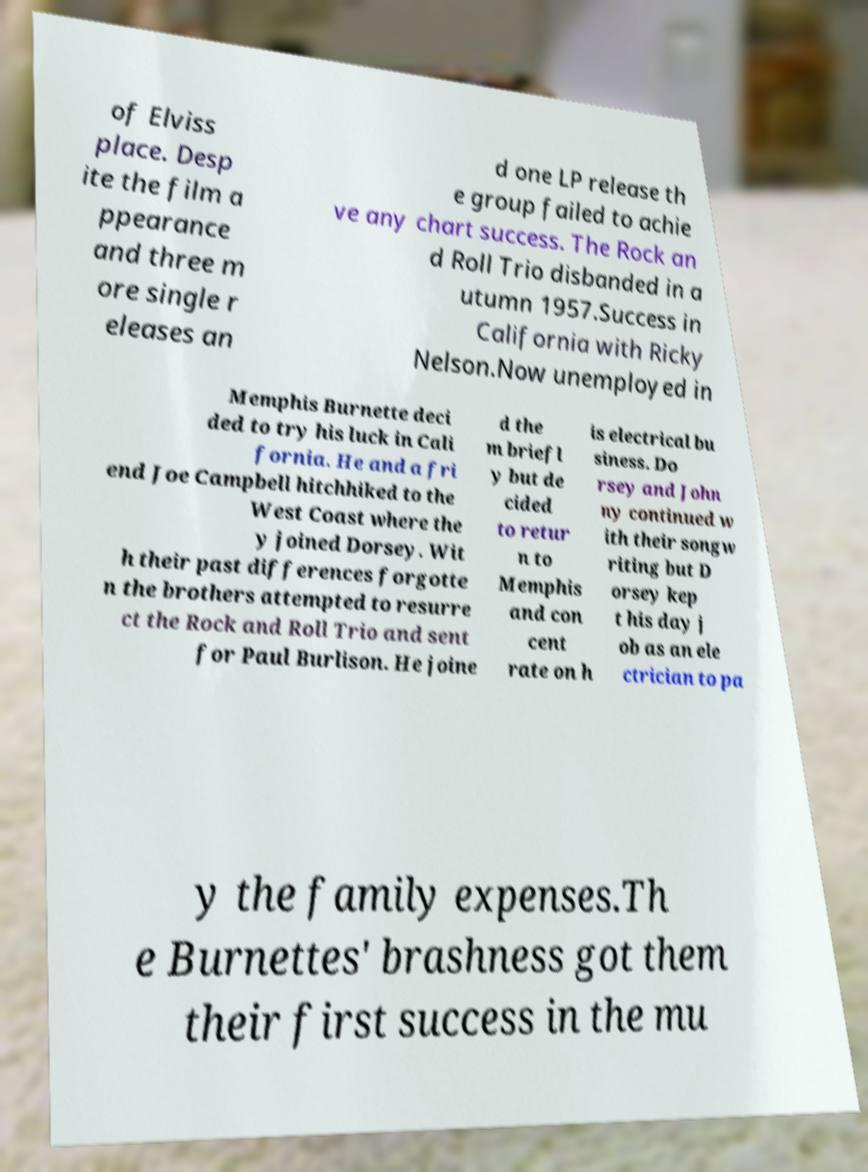Could you extract and type out the text from this image? of Elviss place. Desp ite the film a ppearance and three m ore single r eleases an d one LP release th e group failed to achie ve any chart success. The Rock an d Roll Trio disbanded in a utumn 1957.Success in California with Ricky Nelson.Now unemployed in Memphis Burnette deci ded to try his luck in Cali fornia. He and a fri end Joe Campbell hitchhiked to the West Coast where the y joined Dorsey. Wit h their past differences forgotte n the brothers attempted to resurre ct the Rock and Roll Trio and sent for Paul Burlison. He joine d the m briefl y but de cided to retur n to Memphis and con cent rate on h is electrical bu siness. Do rsey and John ny continued w ith their songw riting but D orsey kep t his day j ob as an ele ctrician to pa y the family expenses.Th e Burnettes' brashness got them their first success in the mu 